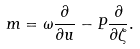<formula> <loc_0><loc_0><loc_500><loc_500>m = \omega \frac { \partial } { \partial u } - P \frac { \partial } { \partial \zeta } .</formula> 